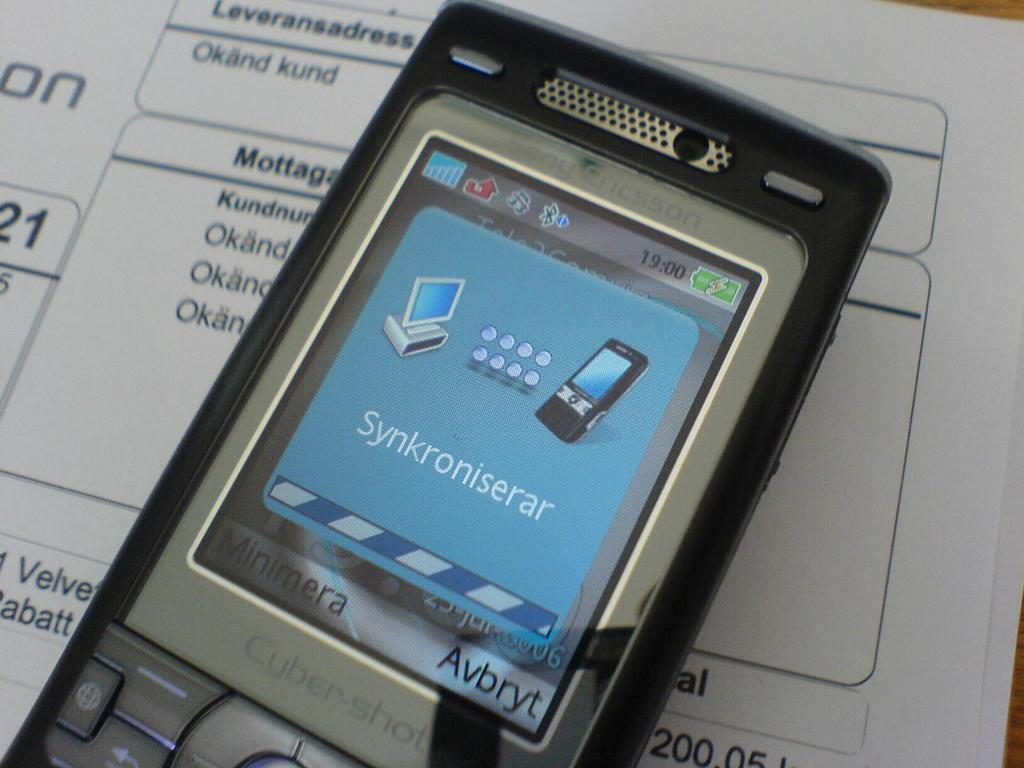<image>
Write a terse but informative summary of the picture. An older cell phone with a display in a foreign language. 